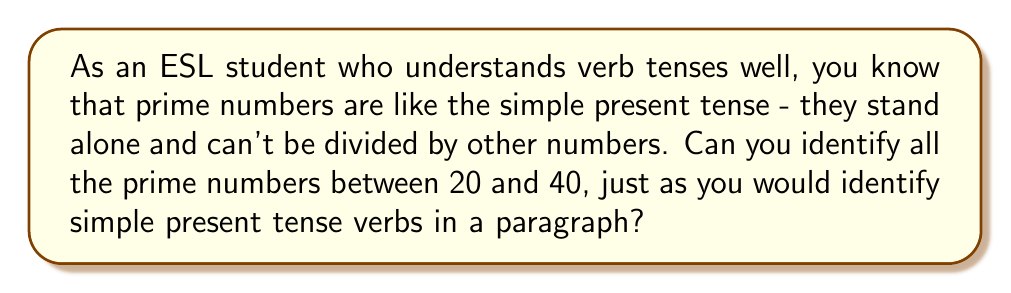Can you answer this question? To identify prime numbers between 20 and 40, we'll use the following steps:

1. List all numbers from 20 to 40:
   20, 21, 22, 23, 24, 25, 26, 27, 28, 29, 30, 31, 32, 33, 34, 35, 36, 37, 38, 39, 40

2. Eliminate numbers divisible by 2 (except 2 itself):
   21, 23, 25, 27, 29, 31, 33, 35, 37, 39

3. Eliminate numbers divisible by 3:
   23, 25, 29, 31, 35, 37

4. Check remaining numbers:
   - 23: Prime (no divisors other than 1 and itself)
   - 25: Not prime (divisible by 5)
   - 29: Prime
   - 31: Prime
   - 35: Not prime (divisible by 5 and 7)
   - 37: Prime

Just as you would identify simple present tense verbs in a sentence, we've identified the "standalone" prime numbers in this range.
Answer: The prime numbers between 20 and 40 are: 23, 29, 31, and 37. 